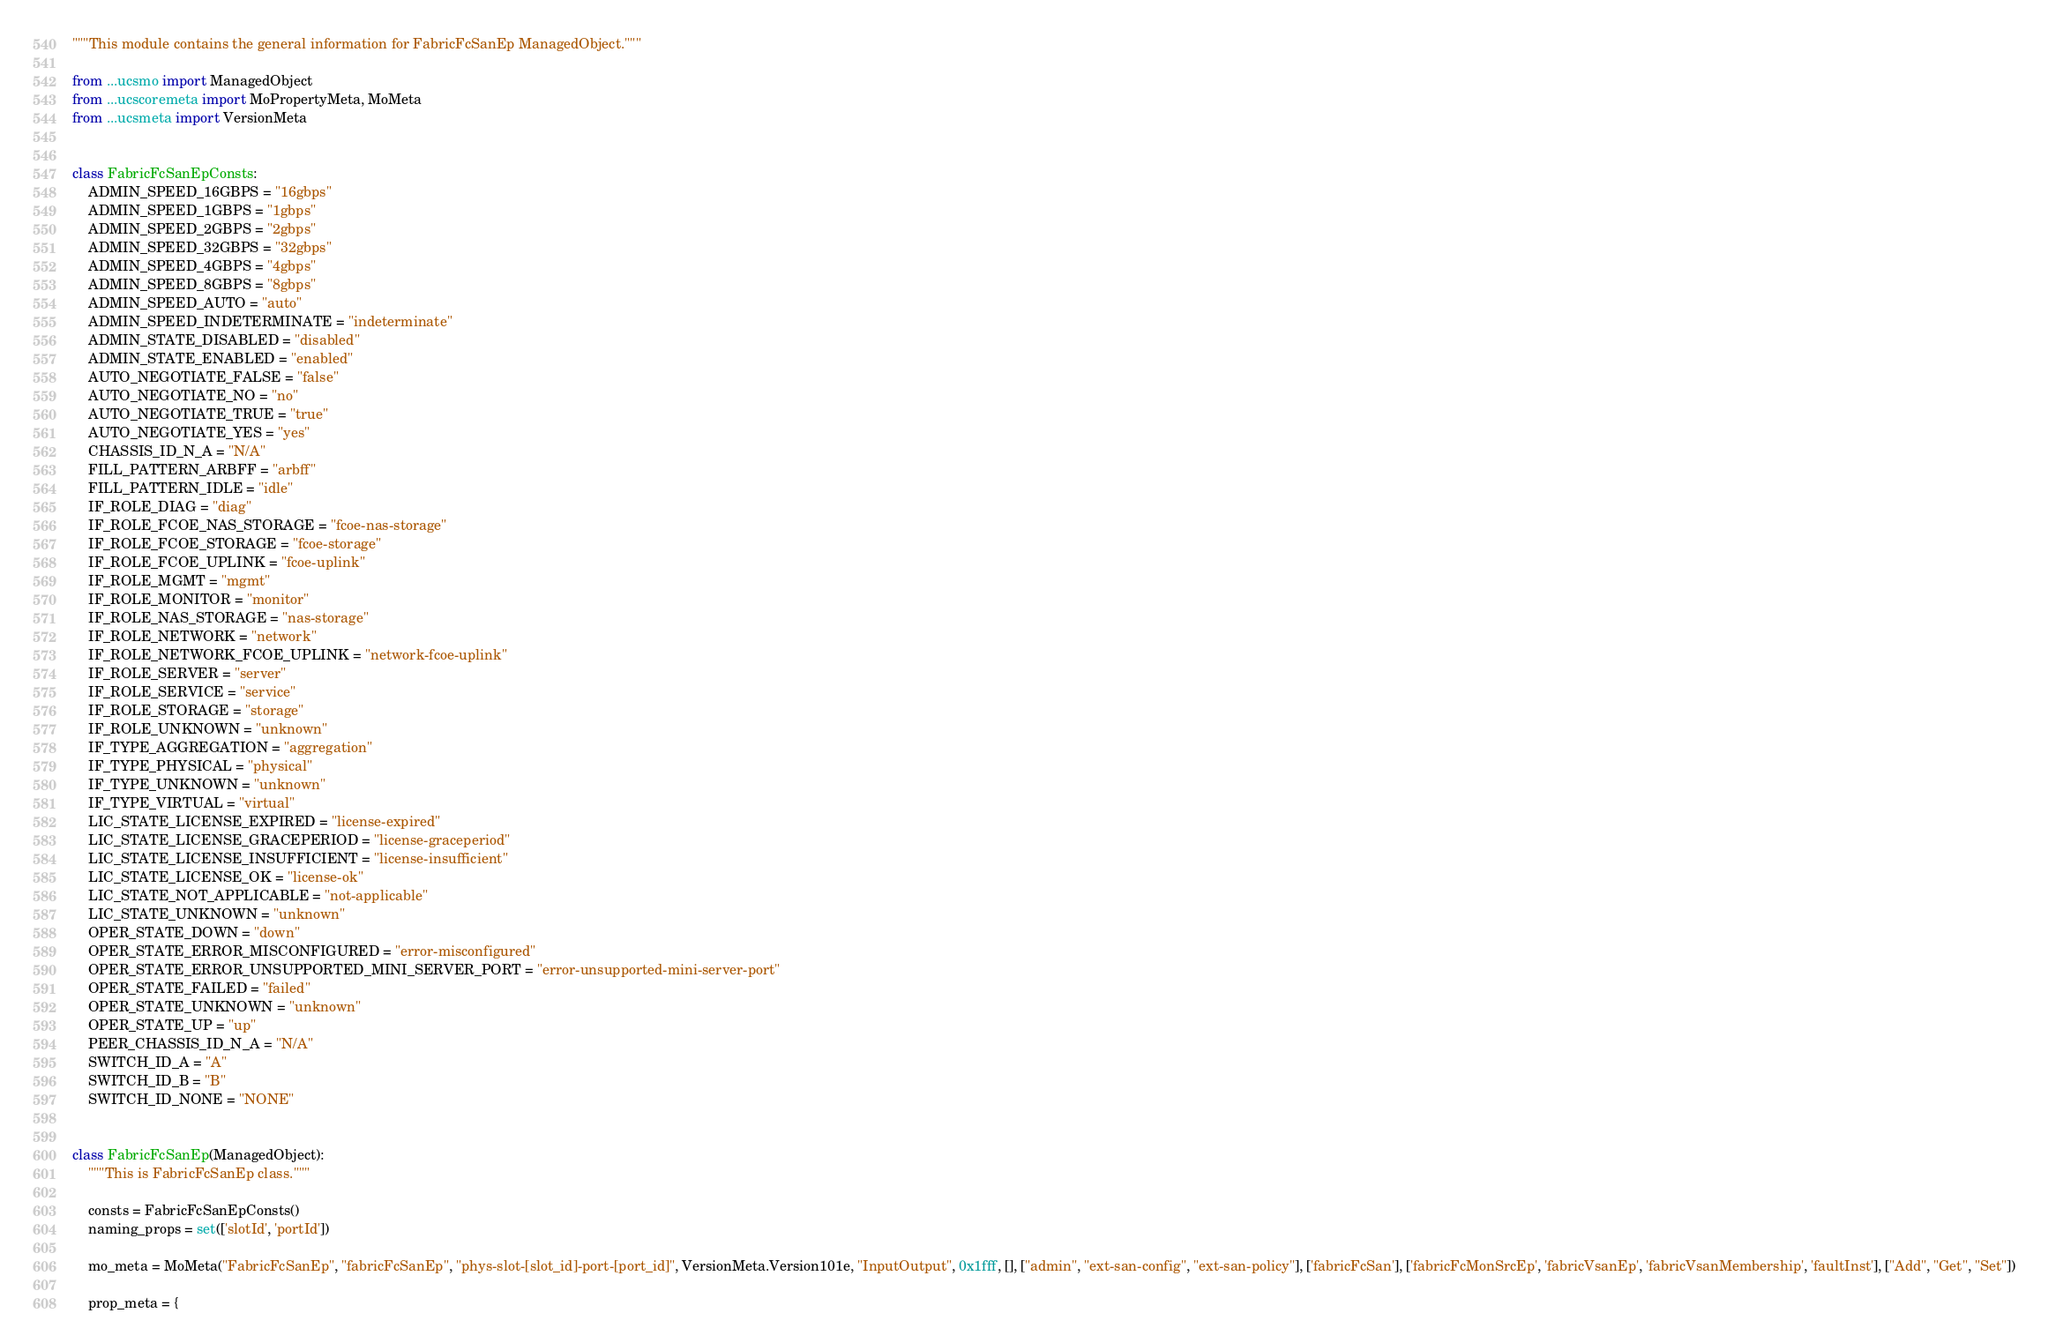Convert code to text. <code><loc_0><loc_0><loc_500><loc_500><_Python_>"""This module contains the general information for FabricFcSanEp ManagedObject."""

from ...ucsmo import ManagedObject
from ...ucscoremeta import MoPropertyMeta, MoMeta
from ...ucsmeta import VersionMeta


class FabricFcSanEpConsts:
    ADMIN_SPEED_16GBPS = "16gbps"
    ADMIN_SPEED_1GBPS = "1gbps"
    ADMIN_SPEED_2GBPS = "2gbps"
    ADMIN_SPEED_32GBPS = "32gbps"
    ADMIN_SPEED_4GBPS = "4gbps"
    ADMIN_SPEED_8GBPS = "8gbps"
    ADMIN_SPEED_AUTO = "auto"
    ADMIN_SPEED_INDETERMINATE = "indeterminate"
    ADMIN_STATE_DISABLED = "disabled"
    ADMIN_STATE_ENABLED = "enabled"
    AUTO_NEGOTIATE_FALSE = "false"
    AUTO_NEGOTIATE_NO = "no"
    AUTO_NEGOTIATE_TRUE = "true"
    AUTO_NEGOTIATE_YES = "yes"
    CHASSIS_ID_N_A = "N/A"
    FILL_PATTERN_ARBFF = "arbff"
    FILL_PATTERN_IDLE = "idle"
    IF_ROLE_DIAG = "diag"
    IF_ROLE_FCOE_NAS_STORAGE = "fcoe-nas-storage"
    IF_ROLE_FCOE_STORAGE = "fcoe-storage"
    IF_ROLE_FCOE_UPLINK = "fcoe-uplink"
    IF_ROLE_MGMT = "mgmt"
    IF_ROLE_MONITOR = "monitor"
    IF_ROLE_NAS_STORAGE = "nas-storage"
    IF_ROLE_NETWORK = "network"
    IF_ROLE_NETWORK_FCOE_UPLINK = "network-fcoe-uplink"
    IF_ROLE_SERVER = "server"
    IF_ROLE_SERVICE = "service"
    IF_ROLE_STORAGE = "storage"
    IF_ROLE_UNKNOWN = "unknown"
    IF_TYPE_AGGREGATION = "aggregation"
    IF_TYPE_PHYSICAL = "physical"
    IF_TYPE_UNKNOWN = "unknown"
    IF_TYPE_VIRTUAL = "virtual"
    LIC_STATE_LICENSE_EXPIRED = "license-expired"
    LIC_STATE_LICENSE_GRACEPERIOD = "license-graceperiod"
    LIC_STATE_LICENSE_INSUFFICIENT = "license-insufficient"
    LIC_STATE_LICENSE_OK = "license-ok"
    LIC_STATE_NOT_APPLICABLE = "not-applicable"
    LIC_STATE_UNKNOWN = "unknown"
    OPER_STATE_DOWN = "down"
    OPER_STATE_ERROR_MISCONFIGURED = "error-misconfigured"
    OPER_STATE_ERROR_UNSUPPORTED_MINI_SERVER_PORT = "error-unsupported-mini-server-port"
    OPER_STATE_FAILED = "failed"
    OPER_STATE_UNKNOWN = "unknown"
    OPER_STATE_UP = "up"
    PEER_CHASSIS_ID_N_A = "N/A"
    SWITCH_ID_A = "A"
    SWITCH_ID_B = "B"
    SWITCH_ID_NONE = "NONE"


class FabricFcSanEp(ManagedObject):
    """This is FabricFcSanEp class."""

    consts = FabricFcSanEpConsts()
    naming_props = set(['slotId', 'portId'])

    mo_meta = MoMeta("FabricFcSanEp", "fabricFcSanEp", "phys-slot-[slot_id]-port-[port_id]", VersionMeta.Version101e, "InputOutput", 0x1fff, [], ["admin", "ext-san-config", "ext-san-policy"], ['fabricFcSan'], ['fabricFcMonSrcEp', 'fabricVsanEp', 'fabricVsanMembership', 'faultInst'], ["Add", "Get", "Set"])

    prop_meta = {</code> 